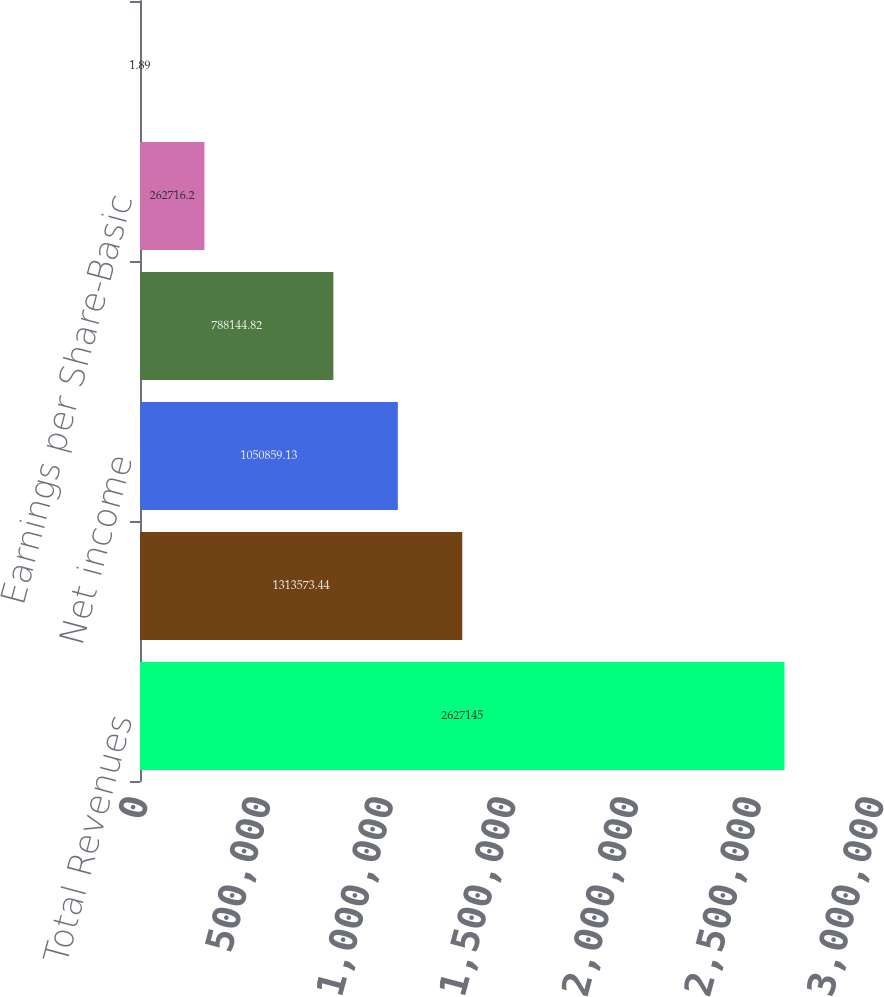Convert chart to OTSL. <chart><loc_0><loc_0><loc_500><loc_500><bar_chart><fcel>Total Revenues<fcel>Income from operations<fcel>Net income<fcel>Weighted-average number of<fcel>Earnings per Share-Basic<fcel>Earnings per Share-Diluted<nl><fcel>2.62714e+06<fcel>1.31357e+06<fcel>1.05086e+06<fcel>788145<fcel>262716<fcel>1.89<nl></chart> 